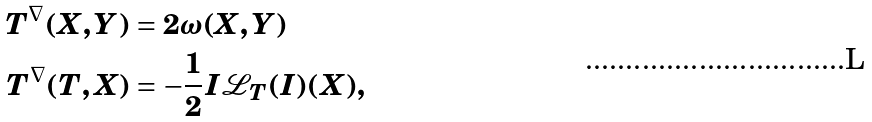<formula> <loc_0><loc_0><loc_500><loc_500>T ^ { \nabla } ( X , Y ) & = 2 \omega ( X , Y ) \\ T ^ { \nabla } ( T , X ) & = - \frac { 1 } { 2 } I { \mathcal { L } } _ { T } ( I ) ( X ) ,</formula> 